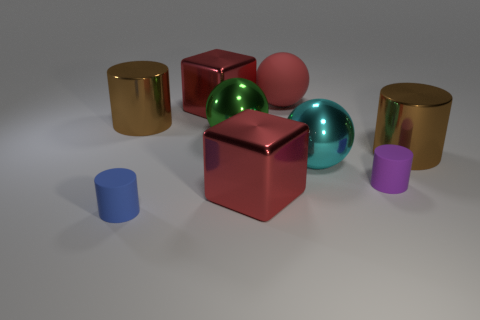Are there any small blue matte cylinders?
Keep it short and to the point. Yes. There is a shiny cylinder on the left side of the large block that is behind the big green shiny ball; are there any red spheres that are to the left of it?
Your answer should be compact. No. What number of small things are cyan metallic spheres or rubber objects?
Your answer should be compact. 2. The rubber cylinder that is the same size as the purple rubber object is what color?
Keep it short and to the point. Blue. There is a cyan object; what number of blue rubber cylinders are right of it?
Your answer should be very brief. 0. Are there any large brown things made of the same material as the blue cylinder?
Keep it short and to the point. No. There is a small rubber thing behind the blue cylinder; what is its color?
Ensure brevity in your answer.  Purple. Are there an equal number of big green objects that are left of the small blue cylinder and large cyan spheres on the right side of the cyan shiny thing?
Keep it short and to the point. Yes. What material is the object on the left side of the rubber cylinder that is left of the red ball?
Ensure brevity in your answer.  Metal. What number of things are shiny objects or small rubber objects that are behind the small blue matte cylinder?
Your answer should be compact. 7. 